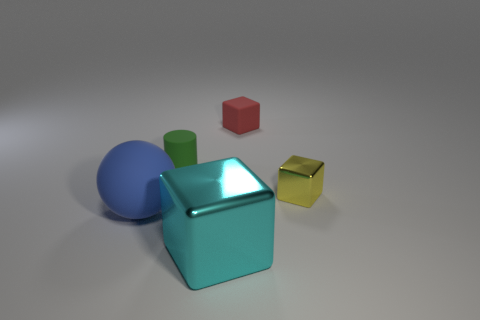Subtract all red blocks. How many blocks are left? 2 Add 3 cyan rubber cylinders. How many objects exist? 8 Subtract all yellow cubes. How many cubes are left? 2 Subtract 1 blocks. How many blocks are left? 2 Add 1 big objects. How many big objects are left? 3 Add 3 blue balls. How many blue balls exist? 4 Subtract 0 green spheres. How many objects are left? 5 Subtract all cylinders. How many objects are left? 4 Subtract all blue cylinders. Subtract all gray balls. How many cylinders are left? 1 Subtract all yellow spheres. How many blue cubes are left? 0 